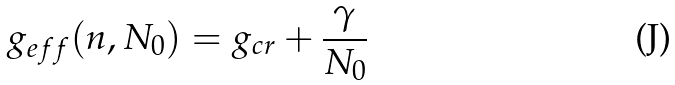Convert formula to latex. <formula><loc_0><loc_0><loc_500><loc_500>g _ { e f f } ( n , N _ { 0 } ) = g _ { c r } + { \frac { \gamma } { N _ { 0 } } }</formula> 